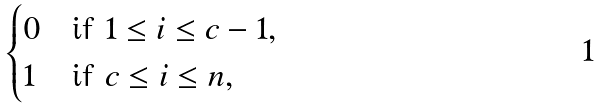Convert formula to latex. <formula><loc_0><loc_0><loc_500><loc_500>\begin{cases} 0 & \text {if } 1 \leq i \leq c - 1 , \\ 1 & \text {if } c \leq i \leq n , \end{cases}</formula> 